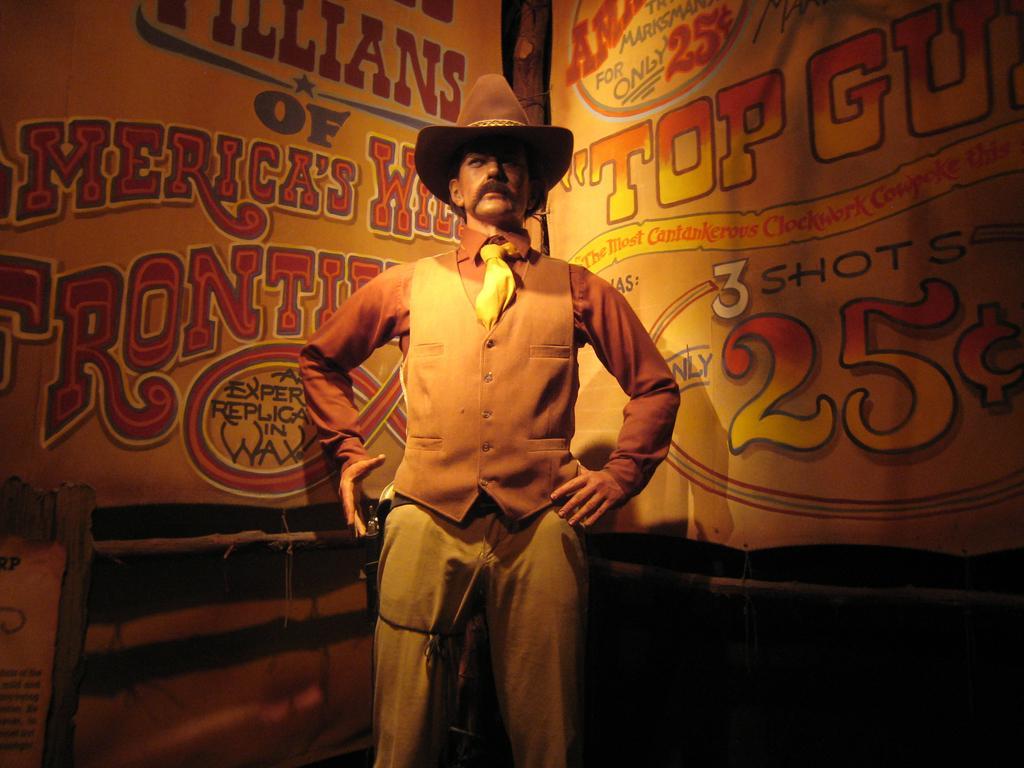Can you describe this image briefly? In this picture there is a person wearing hat is standing and there are two banners which has something written on it is in the background. 